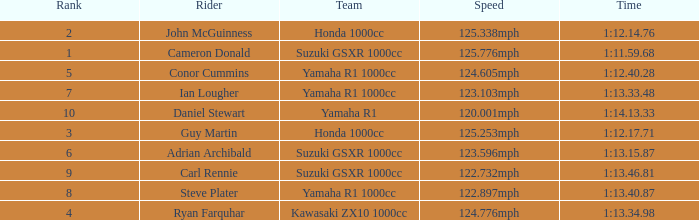What time did team kawasaki zx10 1000cc have? 1:13.34.98. 